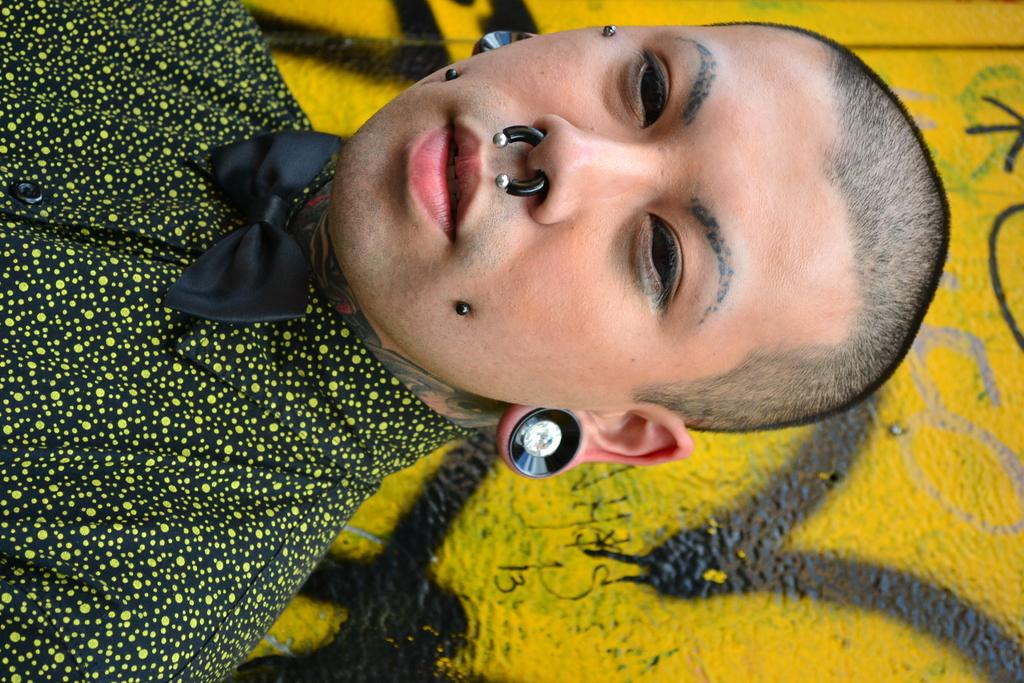Who or what is the main subject of the image? There is a person in the image. What is the person wearing around their neck? The person is wearing a black bow tie. What type of accessory is the person wearing on their ears? The person is wearing earrings. What can be seen on the wall in the background of the image? There is a yellow painting on the wall in the background of the image. What type of shoes is the person wearing in the image? There is no information about the person's shoes in the provided facts, so we cannot determine what type of shoes they are wearing. 